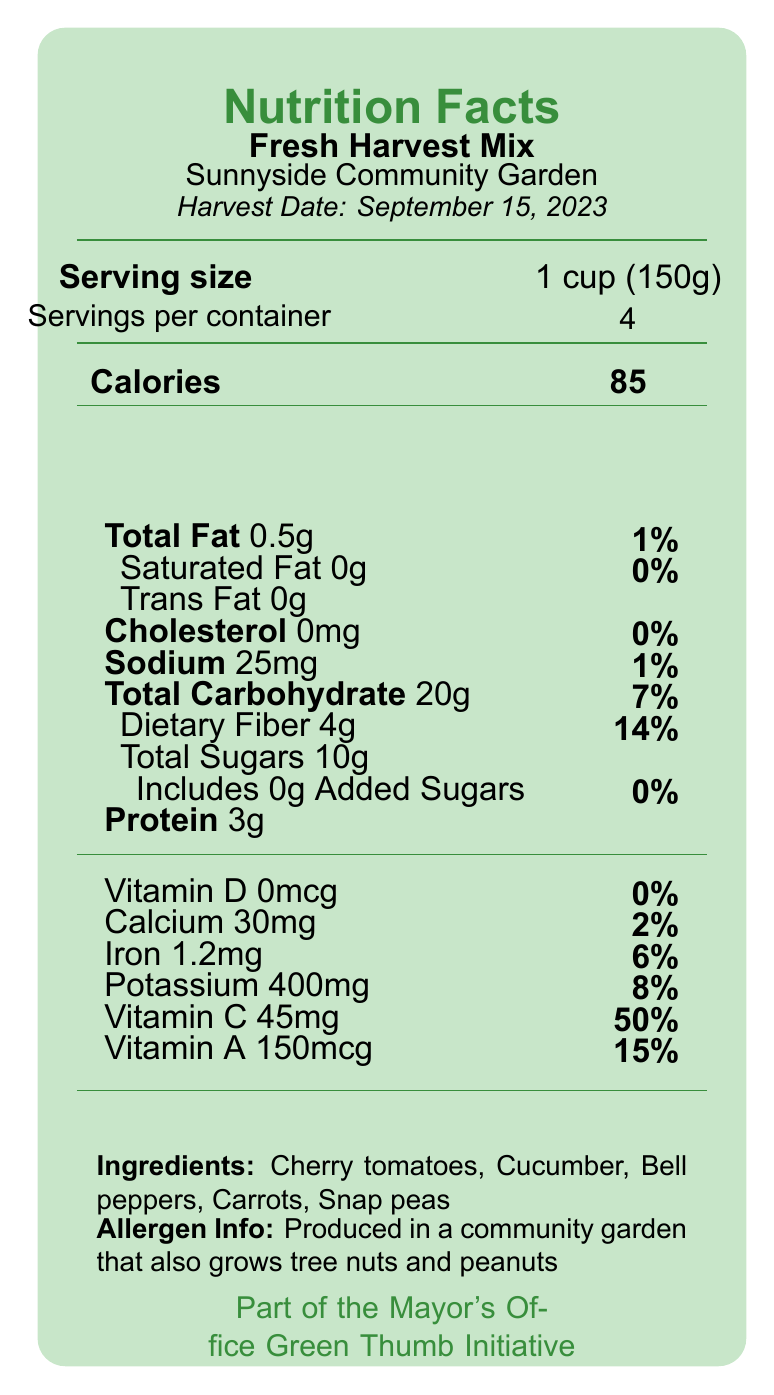what is the name of the product? The product name is printed near the top of the document and reads "Fresh Harvest Mix".
Answer: Fresh Harvest Mix where is the garden located? The location of the garden is listed as "Sunnyside Community Garden" near the top of the document.
Answer: Sunnyside Community Garden how many servings are in the container? The document states "Servings per container: 4" in the nutrition facts section.
Answer: 4 what is the serving size? The serving size is provided as "1 cup (150g)" in the nutrition facts section.
Answer: 1 cup (150g) how many calories are there per serving? The document lists "Calories: 85" for each serving.
Answer: 85 calories what percentage of daily value is the dietary fiber? The percentage of the daily value for dietary fiber is listed as "14%" in the nutrition facts section.
Answer: 14% what ingredients are included in the Fresh Harvest Mix? The ingredients section lists "Cherry tomatoes, Cucumber, Bell peppers, Carrots, Snap peas".
Answer: Cherry tomatoes, Cucumber, Bell peppers, Carrots, Snap peas does the Fresh Harvest Mix contain any added sugars? The amount of added sugars is 0g, indicating there are no added sugars in the product.
Answer: No is the Fresh Harvest Mix safe for someone with a peanut allergy to consume? The allergen information states it is produced in a garden that grows tree nuts and peanuts, which could be a risk for someone with a peanut allergy.
Answer: No which of the following vitamins is present in the highest daily value percentage? A. Vitamin D B. Vitamin C C. Calcium D. Iron Vitamin C has a daily value of 50%, which is higher than Vitamin D (0%), Calcium (2%), and Iron (6%).
Answer: B. Vitamin C what is the main community impact program mentioned? A. Green Thumb Initiative B. Healthy Eating, Active Living (HEAL) Campaign C. Urban Agriculture Expansion Project D. All of the above The document mentions all three programs: Green Thumb Initiative, Healthy Eating, Active Living (HEAL) Campaign, and Urban Agriculture Expansion Project as part of the mayor's office programs.
Answer: D. All of the above can the total fat content be considered significant? The total fat content is 0.5g, which is only 1% of the daily value, indicating it is not significant.
Answer: No summarize the main idea of the document. The document provides comprehensive nutritional information about the Fresh Harvest Mix, including calorie count, vitamin and nutrient content, and servings. Additionally, it highlights the garden's sustainability practices and its contributions to the community through various programs.
Answer: The document is a Nutrition Facts Label for a product called Fresh Harvest Mix from the Sunnyside Community Garden. It includes nutritional information, ingredients, allergen information, and details about the garden's location, the harvest date, sustainability facts, and community impact programs. what percentage of the daily value of sodium does one serving contain? The document states that one serving contains 25mg of sodium, which is 1% of the daily value.
Answer: 1% what is the harvest date for the Fresh Harvest Mix? The harvest date is mentioned as "September 15, 2023" in the document.
Answer: September 15, 2023 how much potassium is in each serving? The potassium content per serving is listed as 400mg in the nutrition facts section.
Answer: 400mg how is the garden irrigated? The document mentions that rainwater harvesting is used for irrigation in the sustainability facts section.
Answer: Rainwater harvesting what is the total carbohydrate content per serving? The nutrition facts section lists the total carbohydrate content as 20g per serving.
Answer: 20g does the document provide specific information about other produce grown in the community garden? The document only mentions that the garden also grows tree nuts and peanuts but does not specify other produce.
Answer: Not enough information 